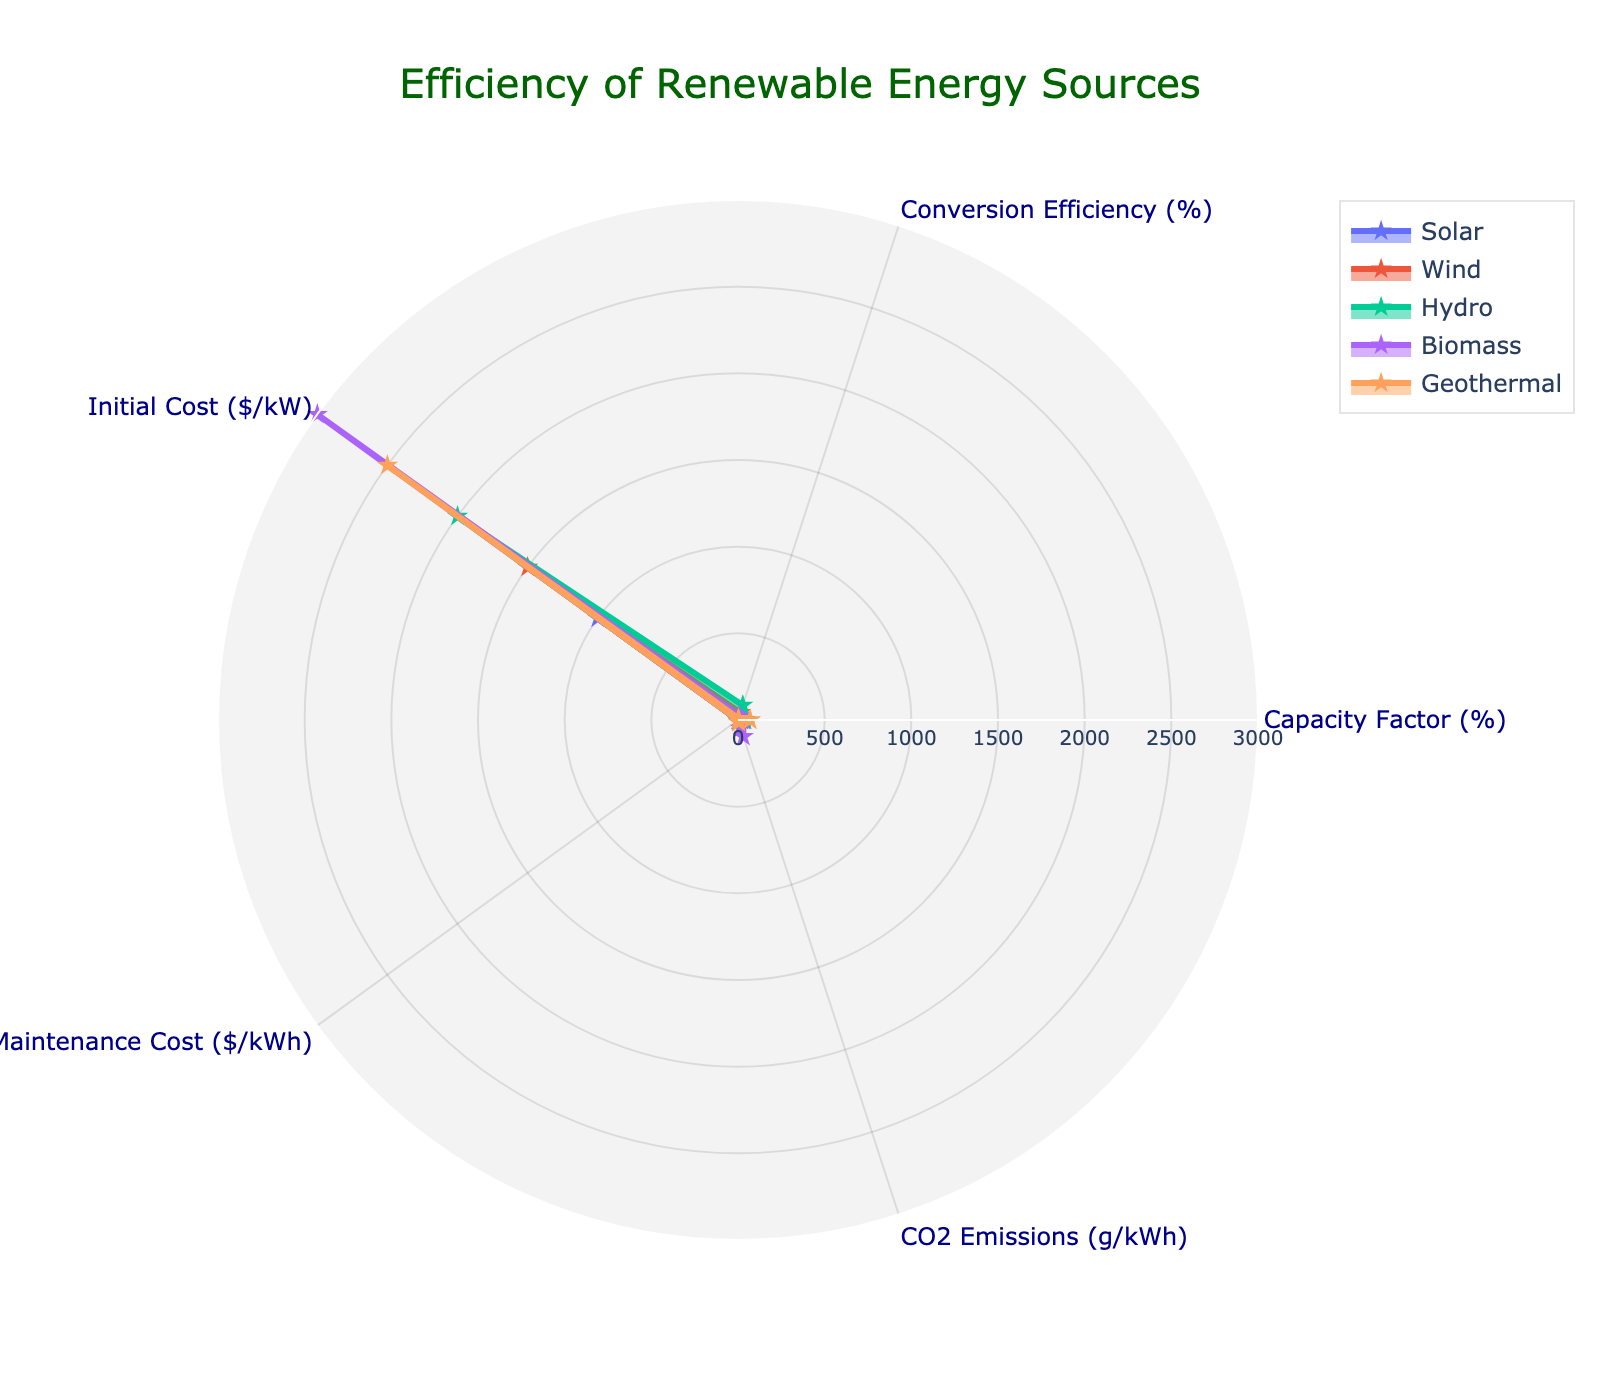What is the title of the figure? The title is usually displayed at the top of the figure and summarizes what the figure is about. In this case, the title reads "Efficiency of Renewable Energy Sources".
Answer: Efficiency of Renewable Energy Sources How many different energy sources are represented in the figure? Each energy source is represented by a series of points connected to form a closed shape on the radar chart. By counting the number of such shapes, you can determine that there are five energy sources.
Answer: Five Which energy source has the highest Capacity Factor? On the radar chart, find the axis labeled "Capacity Factor (%)" and identify which shape has the highest value on this axis. Geothermal reaches the highest point on this axis at 70%.
Answer: Geothermal For which energy source is the Initial Cost the highest? Look at the axis labeled "Initial Cost ($/kW)" and determine which shape extends the farthest along this axis. Biomass has the highest Initial Cost at $3000/kW.
Answer: Biomass Which energy sources have the same Maintenance Cost? Examine the axis labeled "Maintenance Cost ($/kWh)" and find shapes that reach the same point. Both Solar and Hydro have a Maintenance Cost of $0.01/kWh.
Answer: Solar and Hydro What is the difference in Conversion Efficiency between Wind and Biomass? Locate the Conversion Efficiency (%) axis and note the values for Wind and Biomass. Wind has a Conversion Efficiency of 45% and Biomass has 25%. Subtract 25 from 45 to get the difference.
Answer: 20% Which energy source emits the least CO2? On the axis labeled "CO2 Emissions (g/kWh)", find the shape that reaches the lowest value. Hydro has the lowest CO2 emissions at 5 g/kWh.
Answer: Hydro What is the average Initial Cost for Solar, Wind, and Hydro? Identify the Initial Cost values for Solar ($1000/kW), Wind ($1500/kW), and Hydro ($2000/kW). Sum these values to get $4500 and divide by 3.
Answer: $1500/kW Rank the energy sources by their Capacity Factor in ascending order. Analyze the values on the Capacity Factor (%) axis for all energy sources: Solar (20%), Biomass (30%), Wind (35%), Hydro (40%), and Geothermal (70%). Ordering these from lowest to highest gives: Solar, Biomass, Wind, Hydro, Geothermal.
Answer: Solar, Biomass, Wind, Hydro, Geothermal Which energy source has both high Initial Cost and high CO2 Emissions? Find the shape that extends far along the Initial Cost ($/kW) axis and also has a high value on the CO2 Emissions (g/kWh) axis. Biomass meets both criteria with a high initial cost of $3000/kW and CO2 emissions of 100 g/kWh.
Answer: Biomass 